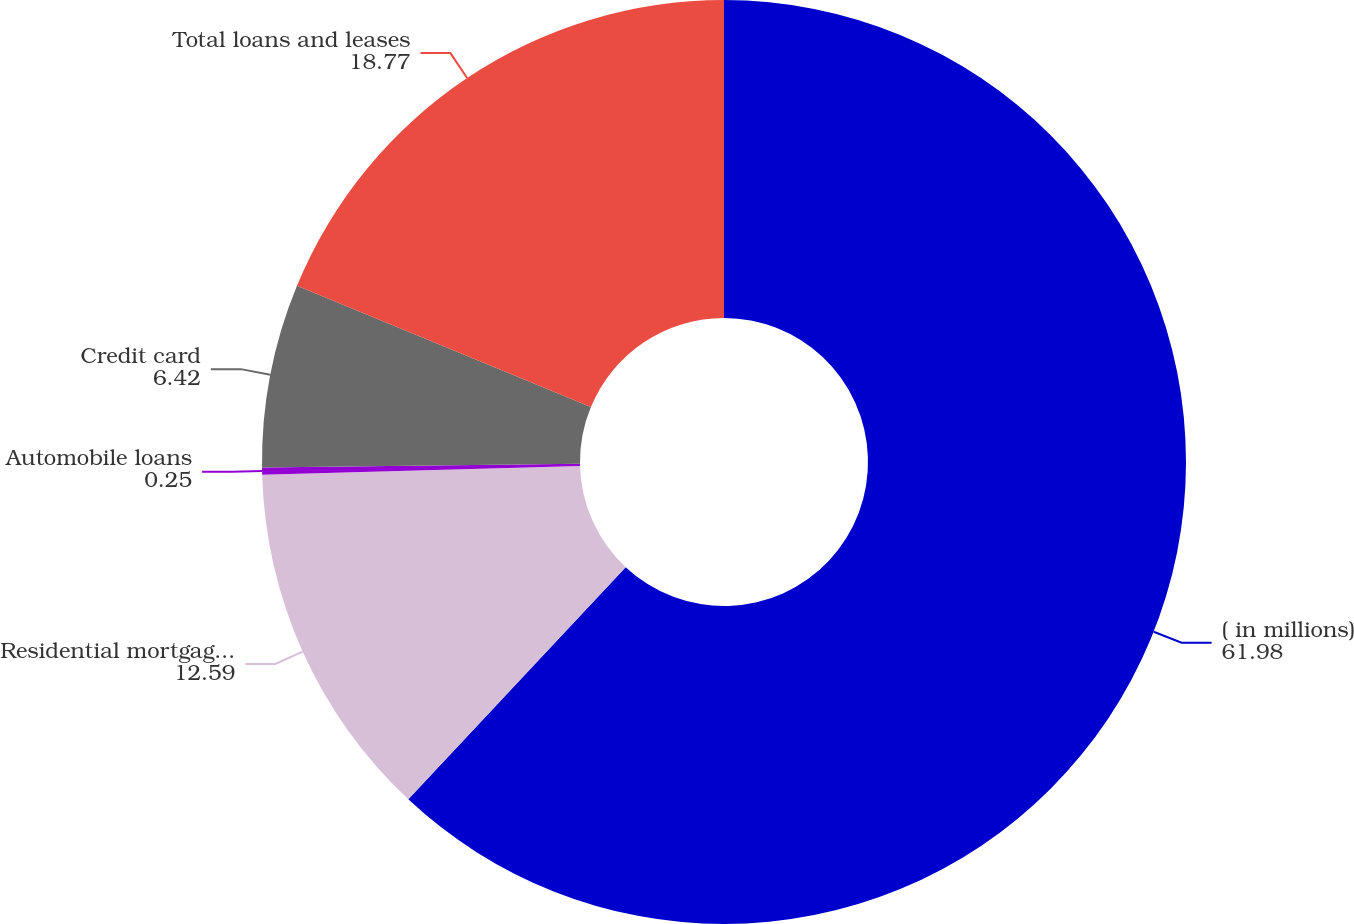Convert chart. <chart><loc_0><loc_0><loc_500><loc_500><pie_chart><fcel>( in millions)<fcel>Residential mortgage loans<fcel>Automobile loans<fcel>Credit card<fcel>Total loans and leases<nl><fcel>61.98%<fcel>12.59%<fcel>0.25%<fcel>6.42%<fcel>18.77%<nl></chart> 